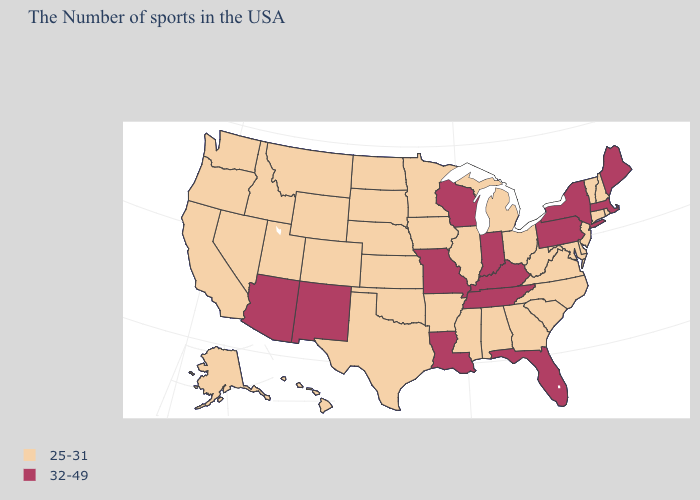Which states have the lowest value in the USA?
Short answer required. Rhode Island, New Hampshire, Vermont, Connecticut, New Jersey, Delaware, Maryland, Virginia, North Carolina, South Carolina, West Virginia, Ohio, Georgia, Michigan, Alabama, Illinois, Mississippi, Arkansas, Minnesota, Iowa, Kansas, Nebraska, Oklahoma, Texas, South Dakota, North Dakota, Wyoming, Colorado, Utah, Montana, Idaho, Nevada, California, Washington, Oregon, Alaska, Hawaii. Which states have the lowest value in the MidWest?
Keep it brief. Ohio, Michigan, Illinois, Minnesota, Iowa, Kansas, Nebraska, South Dakota, North Dakota. Among the states that border Louisiana , which have the lowest value?
Short answer required. Mississippi, Arkansas, Texas. Is the legend a continuous bar?
Be succinct. No. Does Florida have the highest value in the USA?
Keep it brief. Yes. How many symbols are there in the legend?
Keep it brief. 2. Which states have the lowest value in the USA?
Concise answer only. Rhode Island, New Hampshire, Vermont, Connecticut, New Jersey, Delaware, Maryland, Virginia, North Carolina, South Carolina, West Virginia, Ohio, Georgia, Michigan, Alabama, Illinois, Mississippi, Arkansas, Minnesota, Iowa, Kansas, Nebraska, Oklahoma, Texas, South Dakota, North Dakota, Wyoming, Colorado, Utah, Montana, Idaho, Nevada, California, Washington, Oregon, Alaska, Hawaii. Does Maine have the lowest value in the USA?
Keep it brief. No. Does Georgia have the highest value in the USA?
Write a very short answer. No. What is the highest value in the West ?
Write a very short answer. 32-49. What is the highest value in states that border South Carolina?
Give a very brief answer. 25-31. What is the value of Alabama?
Write a very short answer. 25-31. Name the states that have a value in the range 32-49?
Keep it brief. Maine, Massachusetts, New York, Pennsylvania, Florida, Kentucky, Indiana, Tennessee, Wisconsin, Louisiana, Missouri, New Mexico, Arizona. Does the first symbol in the legend represent the smallest category?
Give a very brief answer. Yes. What is the lowest value in the USA?
Quick response, please. 25-31. 